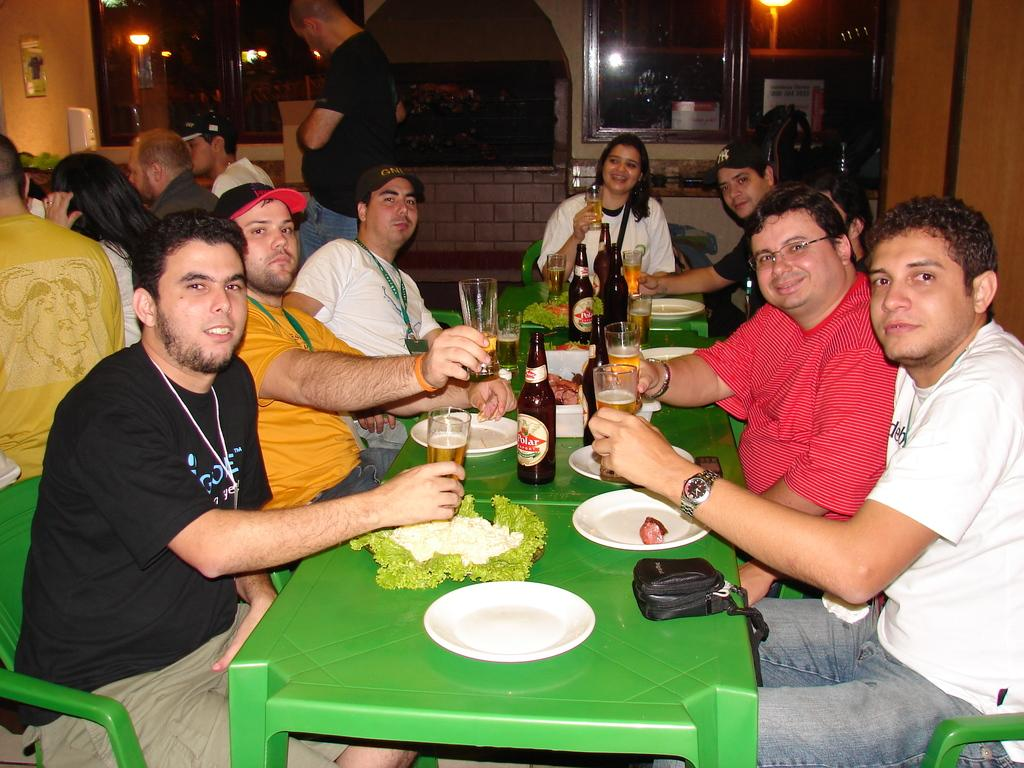How many people are in the image? There is a group of people in the image. What are the people doing in the image? The people are sitting on chairs. What is in front of the people? There is a table in front of the people. What items can be seen on the table? There are plates, glasses, and bottles of beer on the table. What type of milk is being served in the image? There is no milk present in the image; there are only plates, glasses, and bottles of beer on the table. 